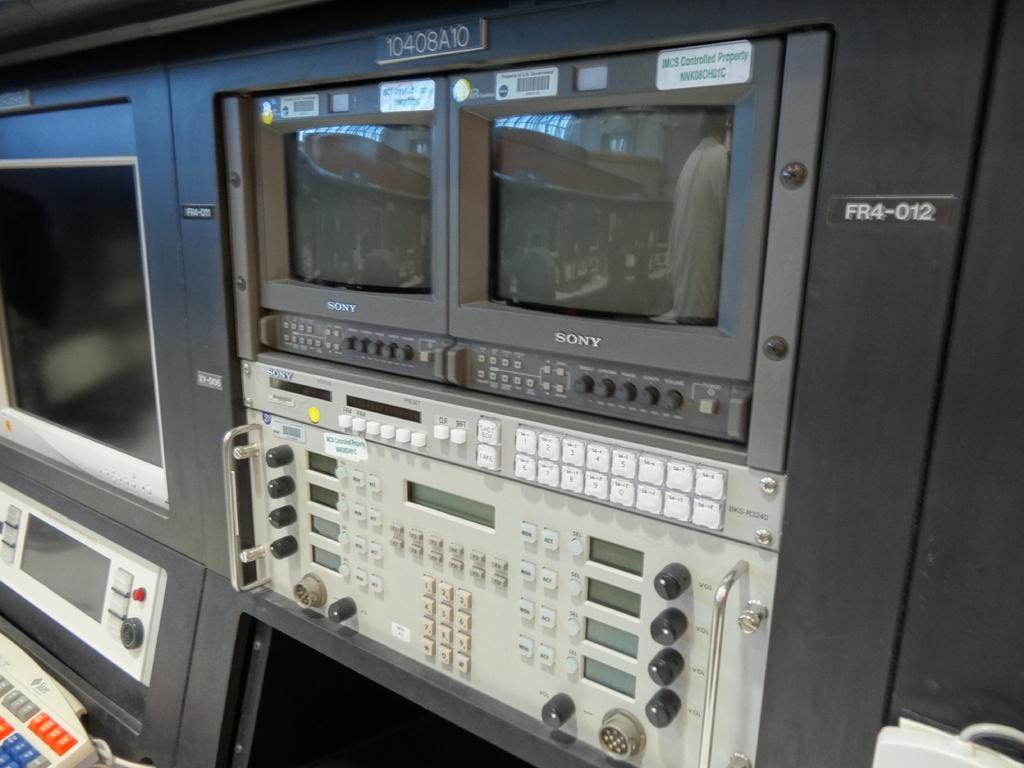<image>
Write a terse but informative summary of the picture. A few SONY monitors sit together with other keys and buttons 